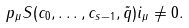Convert formula to latex. <formula><loc_0><loc_0><loc_500><loc_500>p _ { \mu } S ( c _ { 0 } , \dots , c _ { s - 1 } , \tilde { q } ) i _ { \mu } \neq 0 .</formula> 